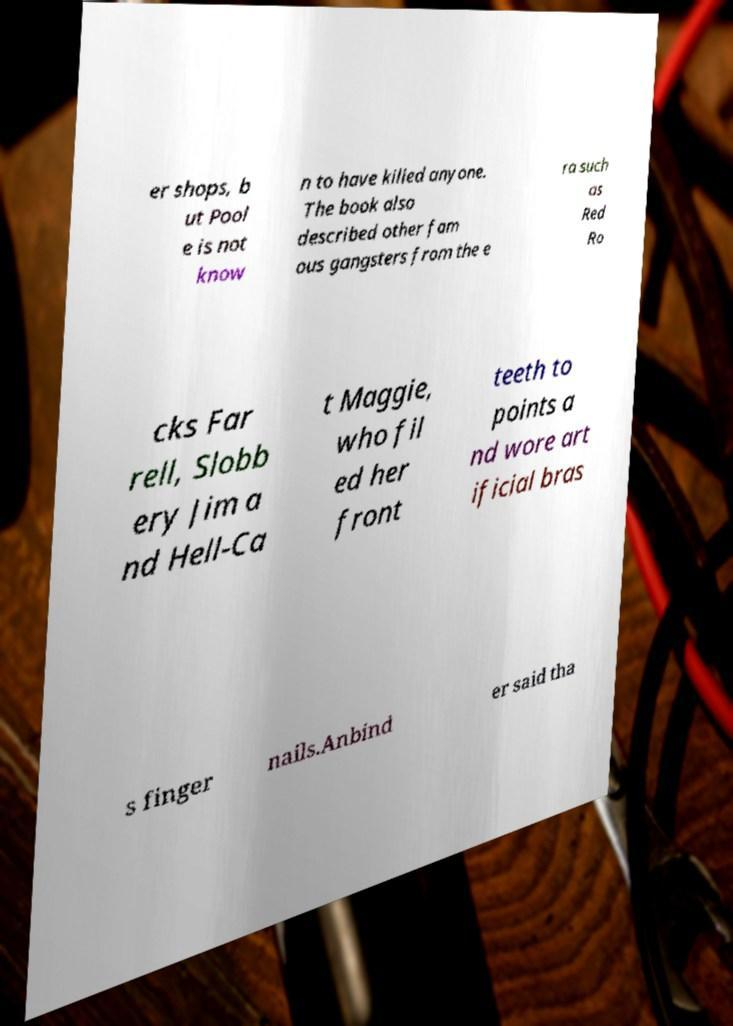Please read and relay the text visible in this image. What does it say? er shops, b ut Pool e is not know n to have killed anyone. The book also described other fam ous gangsters from the e ra such as Red Ro cks Far rell, Slobb ery Jim a nd Hell-Ca t Maggie, who fil ed her front teeth to points a nd wore art ificial bras s finger nails.Anbind er said tha 